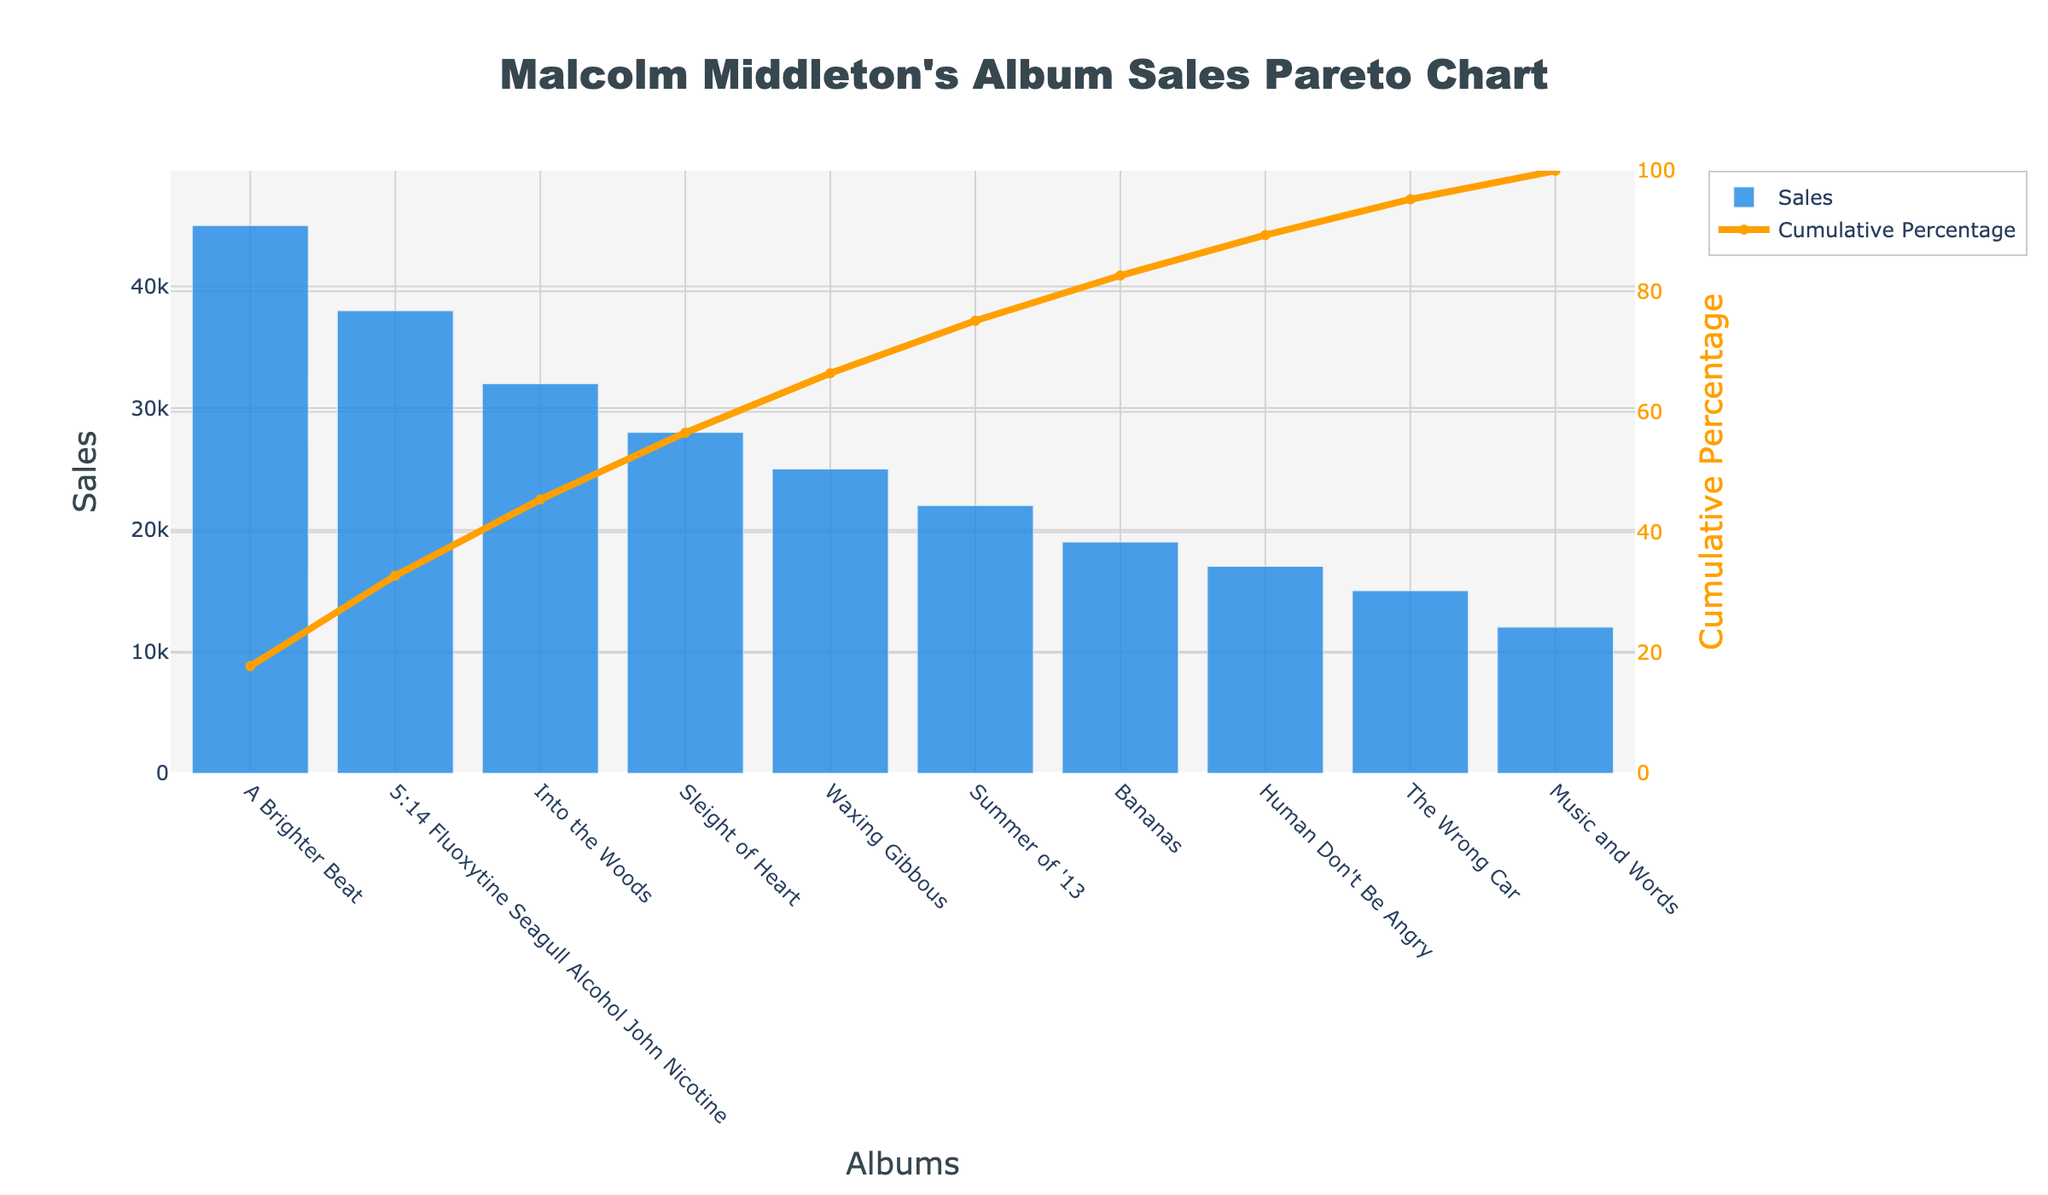What is the title of the chart? The title of the chart is prominently displayed at the top, and it reads, "Malcolm Middleton's Album Sales Pareto Chart".
Answer: Malcolm Middleton's Album Sales Pareto Chart Which album has the highest sales? The album with the highest sales is represented by the tallest bar on the chart, which is labeled with its name. The tallest bar corresponds to "A Brighter Beat".
Answer: A Brighter Beat What is the cumulative percentage of sales reached by the top three albums? To find the cumulative percentage for the top three albums, identify their cumulative percentage values on the y-axis of the secondary line chart: "A Brighter Beat", "5:14 Fluoxytine Seagull Alcohol John Nicotine", and "Into the Woods" read 28%, 52%, and 72% respectively.
Answer: 72% By how much does the sales of the album "Into the Woods" exceed those of "Human Don't Be Angry"? Find the sales values for both albums and subtract the smaller from the larger: 32,000 (Into the Woods) - 17,000 (Human Don't Be Angry).
Answer: 15,000 Is "Waxing Gibbous" sales higher than "Summer of '13"? Compare the lengths of the bars associated with each album. "Waxing Gibbous" is higher than "Summer of '13", meaning its sales are higher.
Answer: Yes How many albums have sales greater than 30,000? Count the number of bars above the 30,000 mark on the y-axis. These are: "A Brighter Beat", "5:14 Fluoxytine Seagull Alcohol John Nicotine", and "Into the Woods".
Answer: 3 Which album's cumulative percentage hits approximately the 50% mark on the cumulative percentage line? Follow the cumulative percentage line to the 50% mark on the y-axis and see which album it aligns with. It aligns closely with "5:14 Fluoxytine Seagull Alcohol John Nicotine".
Answer: 5:14 Fluoxytine Seagull Alcohol John Nicotine What's the difference in cumulative percentage between "Sleight of Heart" and "Bananas"? Identify the cumulative percentages for these albums: "Sleight of Heart" is at 84%, and "Bananas" is at 90%. Calculate the difference: 90% - 84%.
Answer: 6% What is the second-lowest selling album? The second shortest bar in height represents the second-lowest selling album. This bar corresponds to "The Wrong Car".
Answer: The Wrong Car 